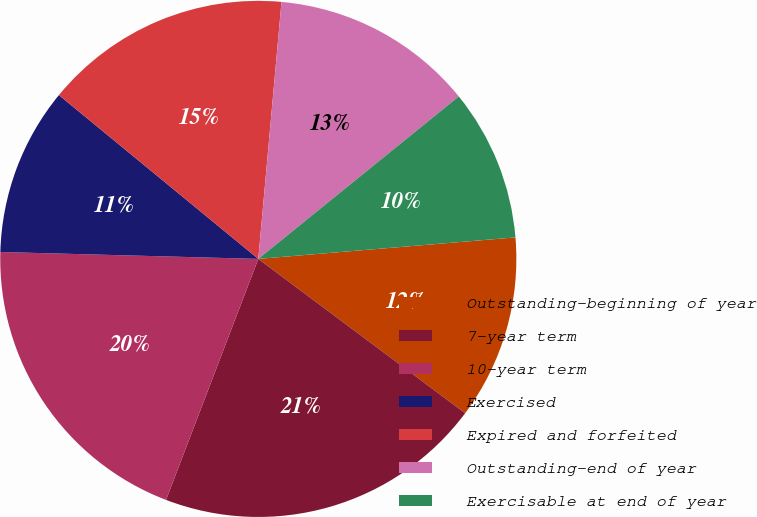Convert chart. <chart><loc_0><loc_0><loc_500><loc_500><pie_chart><fcel>Outstanding-beginning of year<fcel>7-year term<fcel>10-year term<fcel>Exercised<fcel>Expired and forfeited<fcel>Outstanding-end of year<fcel>Exercisable at end of year<nl><fcel>11.53%<fcel>20.62%<fcel>19.61%<fcel>10.52%<fcel>15.49%<fcel>12.73%<fcel>9.51%<nl></chart> 